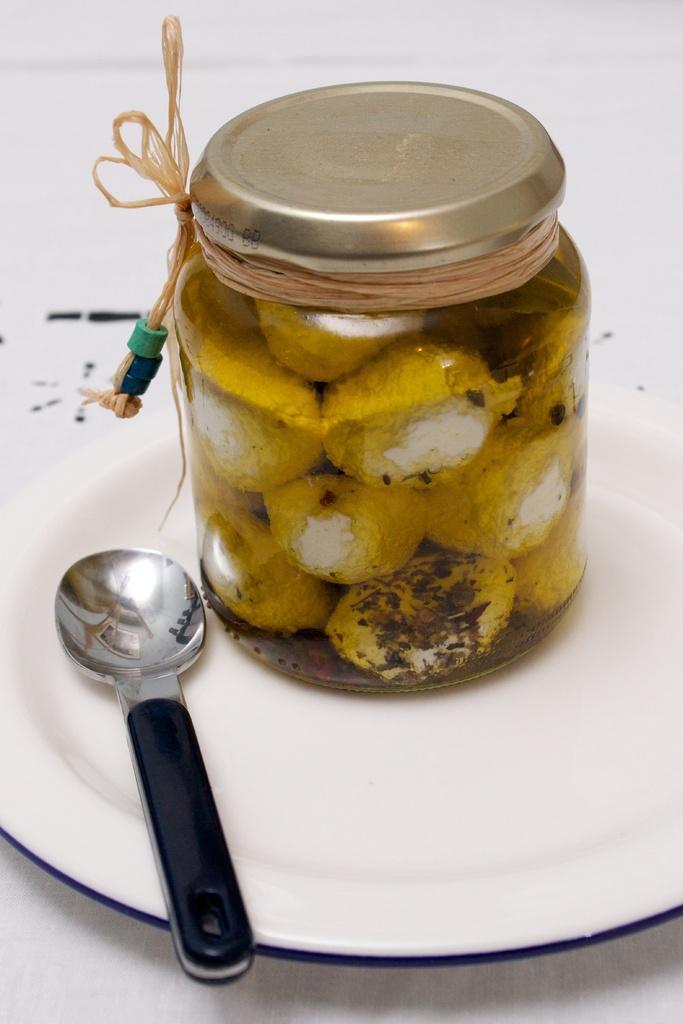Describe this image in one or two sentences. In this image there is a plate on the table. On plate there is a spoon and a jar. Jar is tied with a thread. 